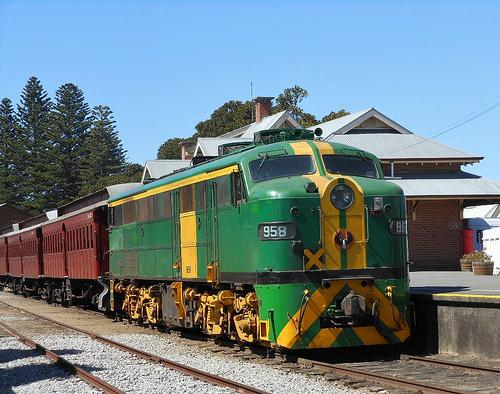Question: where is this scene?
Choices:
A. At the beach house.
B. At a train depot.
C. On a cruise ship.
D. At a playground.
Answer with the letter. Answer: B Question: what is in the photo?
Choices:
A. Station.
B. People.
C. Train.
D. Streetlights.
Answer with the letter. Answer: C Question: why is there a train?
Choices:
A. Walking is too far.
B. Flying is too expensive.
C. Driving would take too long.
D. Travelling.
Answer with the letter. Answer: D Question: who is present?
Choices:
A. A man.
B. A dog.
C. A woman.
D. Nobody.
Answer with the letter. Answer: D 